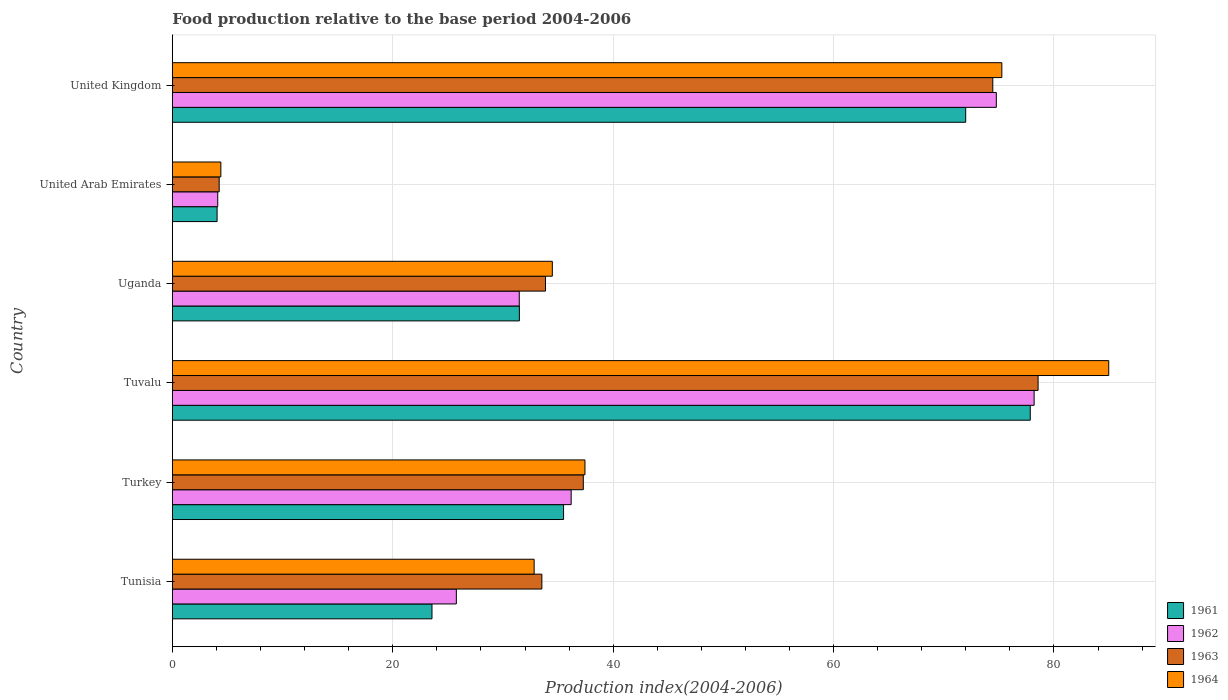Are the number of bars on each tick of the Y-axis equal?
Offer a very short reply. Yes. How many bars are there on the 6th tick from the top?
Provide a succinct answer. 4. What is the food production index in 1964 in Tunisia?
Your answer should be compact. 32.83. Across all countries, what is the maximum food production index in 1963?
Keep it short and to the point. 78.56. Across all countries, what is the minimum food production index in 1964?
Your response must be concise. 4.4. In which country was the food production index in 1963 maximum?
Your response must be concise. Tuvalu. In which country was the food production index in 1961 minimum?
Give a very brief answer. United Arab Emirates. What is the total food production index in 1961 in the graph?
Keep it short and to the point. 244.45. What is the difference between the food production index in 1964 in Uganda and that in United Kingdom?
Keep it short and to the point. -40.79. What is the difference between the food production index in 1961 in Tunisia and the food production index in 1963 in United Kingdom?
Make the answer very short. -50.89. What is the average food production index in 1961 per country?
Keep it short and to the point. 40.74. What is the difference between the food production index in 1961 and food production index in 1964 in United Arab Emirates?
Give a very brief answer. -0.34. What is the ratio of the food production index in 1963 in United Arab Emirates to that in United Kingdom?
Your response must be concise. 0.06. What is the difference between the highest and the second highest food production index in 1962?
Your answer should be compact. 3.43. What is the difference between the highest and the lowest food production index in 1962?
Ensure brevity in your answer.  74.08. What does the 2nd bar from the top in Uganda represents?
Your answer should be very brief. 1963. How many countries are there in the graph?
Your answer should be compact. 6. Are the values on the major ticks of X-axis written in scientific E-notation?
Make the answer very short. No. Does the graph contain grids?
Ensure brevity in your answer.  Yes. Where does the legend appear in the graph?
Your response must be concise. Bottom right. How are the legend labels stacked?
Your answer should be very brief. Vertical. What is the title of the graph?
Provide a succinct answer. Food production relative to the base period 2004-2006. Does "2013" appear as one of the legend labels in the graph?
Your answer should be compact. No. What is the label or title of the X-axis?
Offer a very short reply. Production index(2004-2006). What is the label or title of the Y-axis?
Give a very brief answer. Country. What is the Production index(2004-2006) in 1961 in Tunisia?
Make the answer very short. 23.56. What is the Production index(2004-2006) in 1962 in Tunisia?
Your answer should be very brief. 25.77. What is the Production index(2004-2006) in 1963 in Tunisia?
Ensure brevity in your answer.  33.53. What is the Production index(2004-2006) in 1964 in Tunisia?
Make the answer very short. 32.83. What is the Production index(2004-2006) in 1961 in Turkey?
Offer a terse response. 35.5. What is the Production index(2004-2006) of 1962 in Turkey?
Your answer should be compact. 36.19. What is the Production index(2004-2006) of 1963 in Turkey?
Provide a short and direct response. 37.29. What is the Production index(2004-2006) of 1964 in Turkey?
Offer a very short reply. 37.44. What is the Production index(2004-2006) of 1961 in Tuvalu?
Your response must be concise. 77.85. What is the Production index(2004-2006) of 1962 in Tuvalu?
Make the answer very short. 78.2. What is the Production index(2004-2006) in 1963 in Tuvalu?
Your answer should be compact. 78.56. What is the Production index(2004-2006) in 1964 in Tuvalu?
Provide a succinct answer. 84.97. What is the Production index(2004-2006) of 1961 in Uganda?
Offer a terse response. 31.49. What is the Production index(2004-2006) in 1962 in Uganda?
Offer a terse response. 31.48. What is the Production index(2004-2006) of 1963 in Uganda?
Provide a succinct answer. 33.86. What is the Production index(2004-2006) in 1964 in Uganda?
Your response must be concise. 34.48. What is the Production index(2004-2006) of 1961 in United Arab Emirates?
Offer a terse response. 4.06. What is the Production index(2004-2006) in 1962 in United Arab Emirates?
Provide a succinct answer. 4.12. What is the Production index(2004-2006) of 1963 in United Arab Emirates?
Keep it short and to the point. 4.25. What is the Production index(2004-2006) of 1961 in United Kingdom?
Give a very brief answer. 71.99. What is the Production index(2004-2006) in 1962 in United Kingdom?
Provide a short and direct response. 74.77. What is the Production index(2004-2006) in 1963 in United Kingdom?
Keep it short and to the point. 74.45. What is the Production index(2004-2006) in 1964 in United Kingdom?
Provide a short and direct response. 75.27. Across all countries, what is the maximum Production index(2004-2006) in 1961?
Your response must be concise. 77.85. Across all countries, what is the maximum Production index(2004-2006) of 1962?
Your answer should be very brief. 78.2. Across all countries, what is the maximum Production index(2004-2006) of 1963?
Your answer should be very brief. 78.56. Across all countries, what is the maximum Production index(2004-2006) of 1964?
Ensure brevity in your answer.  84.97. Across all countries, what is the minimum Production index(2004-2006) in 1961?
Give a very brief answer. 4.06. Across all countries, what is the minimum Production index(2004-2006) in 1962?
Your answer should be compact. 4.12. Across all countries, what is the minimum Production index(2004-2006) in 1963?
Your answer should be compact. 4.25. Across all countries, what is the minimum Production index(2004-2006) in 1964?
Your answer should be very brief. 4.4. What is the total Production index(2004-2006) of 1961 in the graph?
Provide a short and direct response. 244.45. What is the total Production index(2004-2006) of 1962 in the graph?
Your answer should be very brief. 250.53. What is the total Production index(2004-2006) of 1963 in the graph?
Offer a terse response. 261.94. What is the total Production index(2004-2006) in 1964 in the graph?
Provide a succinct answer. 269.39. What is the difference between the Production index(2004-2006) of 1961 in Tunisia and that in Turkey?
Offer a terse response. -11.94. What is the difference between the Production index(2004-2006) of 1962 in Tunisia and that in Turkey?
Your answer should be compact. -10.42. What is the difference between the Production index(2004-2006) in 1963 in Tunisia and that in Turkey?
Your answer should be compact. -3.76. What is the difference between the Production index(2004-2006) of 1964 in Tunisia and that in Turkey?
Offer a very short reply. -4.61. What is the difference between the Production index(2004-2006) of 1961 in Tunisia and that in Tuvalu?
Provide a short and direct response. -54.29. What is the difference between the Production index(2004-2006) of 1962 in Tunisia and that in Tuvalu?
Your response must be concise. -52.43. What is the difference between the Production index(2004-2006) in 1963 in Tunisia and that in Tuvalu?
Offer a terse response. -45.03. What is the difference between the Production index(2004-2006) in 1964 in Tunisia and that in Tuvalu?
Your answer should be compact. -52.14. What is the difference between the Production index(2004-2006) in 1961 in Tunisia and that in Uganda?
Provide a short and direct response. -7.93. What is the difference between the Production index(2004-2006) of 1962 in Tunisia and that in Uganda?
Give a very brief answer. -5.71. What is the difference between the Production index(2004-2006) in 1963 in Tunisia and that in Uganda?
Keep it short and to the point. -0.33. What is the difference between the Production index(2004-2006) of 1964 in Tunisia and that in Uganda?
Keep it short and to the point. -1.65. What is the difference between the Production index(2004-2006) in 1961 in Tunisia and that in United Arab Emirates?
Provide a succinct answer. 19.5. What is the difference between the Production index(2004-2006) in 1962 in Tunisia and that in United Arab Emirates?
Give a very brief answer. 21.65. What is the difference between the Production index(2004-2006) in 1963 in Tunisia and that in United Arab Emirates?
Give a very brief answer. 29.28. What is the difference between the Production index(2004-2006) in 1964 in Tunisia and that in United Arab Emirates?
Your answer should be very brief. 28.43. What is the difference between the Production index(2004-2006) in 1961 in Tunisia and that in United Kingdom?
Ensure brevity in your answer.  -48.43. What is the difference between the Production index(2004-2006) of 1962 in Tunisia and that in United Kingdom?
Your response must be concise. -49. What is the difference between the Production index(2004-2006) in 1963 in Tunisia and that in United Kingdom?
Provide a short and direct response. -40.92. What is the difference between the Production index(2004-2006) of 1964 in Tunisia and that in United Kingdom?
Provide a succinct answer. -42.44. What is the difference between the Production index(2004-2006) in 1961 in Turkey and that in Tuvalu?
Make the answer very short. -42.35. What is the difference between the Production index(2004-2006) of 1962 in Turkey and that in Tuvalu?
Keep it short and to the point. -42.01. What is the difference between the Production index(2004-2006) in 1963 in Turkey and that in Tuvalu?
Ensure brevity in your answer.  -41.27. What is the difference between the Production index(2004-2006) in 1964 in Turkey and that in Tuvalu?
Your response must be concise. -47.53. What is the difference between the Production index(2004-2006) in 1961 in Turkey and that in Uganda?
Your answer should be compact. 4.01. What is the difference between the Production index(2004-2006) in 1962 in Turkey and that in Uganda?
Provide a succinct answer. 4.71. What is the difference between the Production index(2004-2006) in 1963 in Turkey and that in Uganda?
Ensure brevity in your answer.  3.43. What is the difference between the Production index(2004-2006) in 1964 in Turkey and that in Uganda?
Make the answer very short. 2.96. What is the difference between the Production index(2004-2006) of 1961 in Turkey and that in United Arab Emirates?
Offer a terse response. 31.44. What is the difference between the Production index(2004-2006) in 1962 in Turkey and that in United Arab Emirates?
Ensure brevity in your answer.  32.07. What is the difference between the Production index(2004-2006) of 1963 in Turkey and that in United Arab Emirates?
Give a very brief answer. 33.04. What is the difference between the Production index(2004-2006) of 1964 in Turkey and that in United Arab Emirates?
Provide a short and direct response. 33.04. What is the difference between the Production index(2004-2006) of 1961 in Turkey and that in United Kingdom?
Offer a terse response. -36.49. What is the difference between the Production index(2004-2006) in 1962 in Turkey and that in United Kingdom?
Offer a very short reply. -38.58. What is the difference between the Production index(2004-2006) of 1963 in Turkey and that in United Kingdom?
Ensure brevity in your answer.  -37.16. What is the difference between the Production index(2004-2006) of 1964 in Turkey and that in United Kingdom?
Provide a succinct answer. -37.83. What is the difference between the Production index(2004-2006) in 1961 in Tuvalu and that in Uganda?
Your answer should be compact. 46.36. What is the difference between the Production index(2004-2006) of 1962 in Tuvalu and that in Uganda?
Your answer should be compact. 46.72. What is the difference between the Production index(2004-2006) in 1963 in Tuvalu and that in Uganda?
Provide a succinct answer. 44.7. What is the difference between the Production index(2004-2006) in 1964 in Tuvalu and that in Uganda?
Offer a very short reply. 50.49. What is the difference between the Production index(2004-2006) in 1961 in Tuvalu and that in United Arab Emirates?
Your answer should be compact. 73.79. What is the difference between the Production index(2004-2006) of 1962 in Tuvalu and that in United Arab Emirates?
Your answer should be very brief. 74.08. What is the difference between the Production index(2004-2006) of 1963 in Tuvalu and that in United Arab Emirates?
Your answer should be very brief. 74.31. What is the difference between the Production index(2004-2006) in 1964 in Tuvalu and that in United Arab Emirates?
Keep it short and to the point. 80.57. What is the difference between the Production index(2004-2006) in 1961 in Tuvalu and that in United Kingdom?
Your answer should be compact. 5.86. What is the difference between the Production index(2004-2006) in 1962 in Tuvalu and that in United Kingdom?
Offer a terse response. 3.43. What is the difference between the Production index(2004-2006) of 1963 in Tuvalu and that in United Kingdom?
Give a very brief answer. 4.11. What is the difference between the Production index(2004-2006) in 1961 in Uganda and that in United Arab Emirates?
Make the answer very short. 27.43. What is the difference between the Production index(2004-2006) of 1962 in Uganda and that in United Arab Emirates?
Keep it short and to the point. 27.36. What is the difference between the Production index(2004-2006) of 1963 in Uganda and that in United Arab Emirates?
Ensure brevity in your answer.  29.61. What is the difference between the Production index(2004-2006) in 1964 in Uganda and that in United Arab Emirates?
Make the answer very short. 30.08. What is the difference between the Production index(2004-2006) of 1961 in Uganda and that in United Kingdom?
Your response must be concise. -40.5. What is the difference between the Production index(2004-2006) of 1962 in Uganda and that in United Kingdom?
Make the answer very short. -43.29. What is the difference between the Production index(2004-2006) in 1963 in Uganda and that in United Kingdom?
Ensure brevity in your answer.  -40.59. What is the difference between the Production index(2004-2006) in 1964 in Uganda and that in United Kingdom?
Provide a short and direct response. -40.79. What is the difference between the Production index(2004-2006) of 1961 in United Arab Emirates and that in United Kingdom?
Offer a terse response. -67.93. What is the difference between the Production index(2004-2006) of 1962 in United Arab Emirates and that in United Kingdom?
Give a very brief answer. -70.65. What is the difference between the Production index(2004-2006) in 1963 in United Arab Emirates and that in United Kingdom?
Your answer should be compact. -70.2. What is the difference between the Production index(2004-2006) of 1964 in United Arab Emirates and that in United Kingdom?
Your response must be concise. -70.87. What is the difference between the Production index(2004-2006) in 1961 in Tunisia and the Production index(2004-2006) in 1962 in Turkey?
Offer a very short reply. -12.63. What is the difference between the Production index(2004-2006) of 1961 in Tunisia and the Production index(2004-2006) of 1963 in Turkey?
Offer a very short reply. -13.73. What is the difference between the Production index(2004-2006) in 1961 in Tunisia and the Production index(2004-2006) in 1964 in Turkey?
Keep it short and to the point. -13.88. What is the difference between the Production index(2004-2006) of 1962 in Tunisia and the Production index(2004-2006) of 1963 in Turkey?
Offer a terse response. -11.52. What is the difference between the Production index(2004-2006) of 1962 in Tunisia and the Production index(2004-2006) of 1964 in Turkey?
Offer a terse response. -11.67. What is the difference between the Production index(2004-2006) of 1963 in Tunisia and the Production index(2004-2006) of 1964 in Turkey?
Ensure brevity in your answer.  -3.91. What is the difference between the Production index(2004-2006) in 1961 in Tunisia and the Production index(2004-2006) in 1962 in Tuvalu?
Give a very brief answer. -54.64. What is the difference between the Production index(2004-2006) of 1961 in Tunisia and the Production index(2004-2006) of 1963 in Tuvalu?
Provide a short and direct response. -55. What is the difference between the Production index(2004-2006) of 1961 in Tunisia and the Production index(2004-2006) of 1964 in Tuvalu?
Provide a succinct answer. -61.41. What is the difference between the Production index(2004-2006) of 1962 in Tunisia and the Production index(2004-2006) of 1963 in Tuvalu?
Provide a succinct answer. -52.79. What is the difference between the Production index(2004-2006) in 1962 in Tunisia and the Production index(2004-2006) in 1964 in Tuvalu?
Provide a short and direct response. -59.2. What is the difference between the Production index(2004-2006) in 1963 in Tunisia and the Production index(2004-2006) in 1964 in Tuvalu?
Your response must be concise. -51.44. What is the difference between the Production index(2004-2006) in 1961 in Tunisia and the Production index(2004-2006) in 1962 in Uganda?
Provide a short and direct response. -7.92. What is the difference between the Production index(2004-2006) of 1961 in Tunisia and the Production index(2004-2006) of 1964 in Uganda?
Ensure brevity in your answer.  -10.92. What is the difference between the Production index(2004-2006) of 1962 in Tunisia and the Production index(2004-2006) of 1963 in Uganda?
Your answer should be compact. -8.09. What is the difference between the Production index(2004-2006) of 1962 in Tunisia and the Production index(2004-2006) of 1964 in Uganda?
Offer a very short reply. -8.71. What is the difference between the Production index(2004-2006) of 1963 in Tunisia and the Production index(2004-2006) of 1964 in Uganda?
Keep it short and to the point. -0.95. What is the difference between the Production index(2004-2006) in 1961 in Tunisia and the Production index(2004-2006) in 1962 in United Arab Emirates?
Keep it short and to the point. 19.44. What is the difference between the Production index(2004-2006) in 1961 in Tunisia and the Production index(2004-2006) in 1963 in United Arab Emirates?
Ensure brevity in your answer.  19.31. What is the difference between the Production index(2004-2006) of 1961 in Tunisia and the Production index(2004-2006) of 1964 in United Arab Emirates?
Give a very brief answer. 19.16. What is the difference between the Production index(2004-2006) in 1962 in Tunisia and the Production index(2004-2006) in 1963 in United Arab Emirates?
Your response must be concise. 21.52. What is the difference between the Production index(2004-2006) of 1962 in Tunisia and the Production index(2004-2006) of 1964 in United Arab Emirates?
Keep it short and to the point. 21.37. What is the difference between the Production index(2004-2006) of 1963 in Tunisia and the Production index(2004-2006) of 1964 in United Arab Emirates?
Your answer should be compact. 29.13. What is the difference between the Production index(2004-2006) of 1961 in Tunisia and the Production index(2004-2006) of 1962 in United Kingdom?
Your response must be concise. -51.21. What is the difference between the Production index(2004-2006) of 1961 in Tunisia and the Production index(2004-2006) of 1963 in United Kingdom?
Ensure brevity in your answer.  -50.89. What is the difference between the Production index(2004-2006) of 1961 in Tunisia and the Production index(2004-2006) of 1964 in United Kingdom?
Your response must be concise. -51.71. What is the difference between the Production index(2004-2006) in 1962 in Tunisia and the Production index(2004-2006) in 1963 in United Kingdom?
Keep it short and to the point. -48.68. What is the difference between the Production index(2004-2006) of 1962 in Tunisia and the Production index(2004-2006) of 1964 in United Kingdom?
Your answer should be compact. -49.5. What is the difference between the Production index(2004-2006) in 1963 in Tunisia and the Production index(2004-2006) in 1964 in United Kingdom?
Offer a terse response. -41.74. What is the difference between the Production index(2004-2006) of 1961 in Turkey and the Production index(2004-2006) of 1962 in Tuvalu?
Your response must be concise. -42.7. What is the difference between the Production index(2004-2006) in 1961 in Turkey and the Production index(2004-2006) in 1963 in Tuvalu?
Offer a terse response. -43.06. What is the difference between the Production index(2004-2006) in 1961 in Turkey and the Production index(2004-2006) in 1964 in Tuvalu?
Ensure brevity in your answer.  -49.47. What is the difference between the Production index(2004-2006) of 1962 in Turkey and the Production index(2004-2006) of 1963 in Tuvalu?
Your answer should be very brief. -42.37. What is the difference between the Production index(2004-2006) in 1962 in Turkey and the Production index(2004-2006) in 1964 in Tuvalu?
Ensure brevity in your answer.  -48.78. What is the difference between the Production index(2004-2006) in 1963 in Turkey and the Production index(2004-2006) in 1964 in Tuvalu?
Offer a very short reply. -47.68. What is the difference between the Production index(2004-2006) in 1961 in Turkey and the Production index(2004-2006) in 1962 in Uganda?
Provide a short and direct response. 4.02. What is the difference between the Production index(2004-2006) of 1961 in Turkey and the Production index(2004-2006) of 1963 in Uganda?
Give a very brief answer. 1.64. What is the difference between the Production index(2004-2006) of 1962 in Turkey and the Production index(2004-2006) of 1963 in Uganda?
Ensure brevity in your answer.  2.33. What is the difference between the Production index(2004-2006) of 1962 in Turkey and the Production index(2004-2006) of 1964 in Uganda?
Offer a very short reply. 1.71. What is the difference between the Production index(2004-2006) of 1963 in Turkey and the Production index(2004-2006) of 1964 in Uganda?
Give a very brief answer. 2.81. What is the difference between the Production index(2004-2006) in 1961 in Turkey and the Production index(2004-2006) in 1962 in United Arab Emirates?
Keep it short and to the point. 31.38. What is the difference between the Production index(2004-2006) in 1961 in Turkey and the Production index(2004-2006) in 1963 in United Arab Emirates?
Make the answer very short. 31.25. What is the difference between the Production index(2004-2006) in 1961 in Turkey and the Production index(2004-2006) in 1964 in United Arab Emirates?
Provide a short and direct response. 31.1. What is the difference between the Production index(2004-2006) of 1962 in Turkey and the Production index(2004-2006) of 1963 in United Arab Emirates?
Offer a terse response. 31.94. What is the difference between the Production index(2004-2006) of 1962 in Turkey and the Production index(2004-2006) of 1964 in United Arab Emirates?
Your answer should be compact. 31.79. What is the difference between the Production index(2004-2006) in 1963 in Turkey and the Production index(2004-2006) in 1964 in United Arab Emirates?
Keep it short and to the point. 32.89. What is the difference between the Production index(2004-2006) in 1961 in Turkey and the Production index(2004-2006) in 1962 in United Kingdom?
Your answer should be very brief. -39.27. What is the difference between the Production index(2004-2006) in 1961 in Turkey and the Production index(2004-2006) in 1963 in United Kingdom?
Your answer should be very brief. -38.95. What is the difference between the Production index(2004-2006) of 1961 in Turkey and the Production index(2004-2006) of 1964 in United Kingdom?
Offer a very short reply. -39.77. What is the difference between the Production index(2004-2006) in 1962 in Turkey and the Production index(2004-2006) in 1963 in United Kingdom?
Provide a succinct answer. -38.26. What is the difference between the Production index(2004-2006) in 1962 in Turkey and the Production index(2004-2006) in 1964 in United Kingdom?
Offer a terse response. -39.08. What is the difference between the Production index(2004-2006) in 1963 in Turkey and the Production index(2004-2006) in 1964 in United Kingdom?
Provide a succinct answer. -37.98. What is the difference between the Production index(2004-2006) of 1961 in Tuvalu and the Production index(2004-2006) of 1962 in Uganda?
Offer a terse response. 46.37. What is the difference between the Production index(2004-2006) in 1961 in Tuvalu and the Production index(2004-2006) in 1963 in Uganda?
Provide a short and direct response. 43.99. What is the difference between the Production index(2004-2006) of 1961 in Tuvalu and the Production index(2004-2006) of 1964 in Uganda?
Ensure brevity in your answer.  43.37. What is the difference between the Production index(2004-2006) in 1962 in Tuvalu and the Production index(2004-2006) in 1963 in Uganda?
Give a very brief answer. 44.34. What is the difference between the Production index(2004-2006) in 1962 in Tuvalu and the Production index(2004-2006) in 1964 in Uganda?
Make the answer very short. 43.72. What is the difference between the Production index(2004-2006) in 1963 in Tuvalu and the Production index(2004-2006) in 1964 in Uganda?
Your response must be concise. 44.08. What is the difference between the Production index(2004-2006) of 1961 in Tuvalu and the Production index(2004-2006) of 1962 in United Arab Emirates?
Give a very brief answer. 73.73. What is the difference between the Production index(2004-2006) of 1961 in Tuvalu and the Production index(2004-2006) of 1963 in United Arab Emirates?
Your answer should be compact. 73.6. What is the difference between the Production index(2004-2006) in 1961 in Tuvalu and the Production index(2004-2006) in 1964 in United Arab Emirates?
Offer a very short reply. 73.45. What is the difference between the Production index(2004-2006) of 1962 in Tuvalu and the Production index(2004-2006) of 1963 in United Arab Emirates?
Make the answer very short. 73.95. What is the difference between the Production index(2004-2006) in 1962 in Tuvalu and the Production index(2004-2006) in 1964 in United Arab Emirates?
Your answer should be compact. 73.8. What is the difference between the Production index(2004-2006) of 1963 in Tuvalu and the Production index(2004-2006) of 1964 in United Arab Emirates?
Your answer should be compact. 74.16. What is the difference between the Production index(2004-2006) in 1961 in Tuvalu and the Production index(2004-2006) in 1962 in United Kingdom?
Ensure brevity in your answer.  3.08. What is the difference between the Production index(2004-2006) of 1961 in Tuvalu and the Production index(2004-2006) of 1964 in United Kingdom?
Your response must be concise. 2.58. What is the difference between the Production index(2004-2006) of 1962 in Tuvalu and the Production index(2004-2006) of 1963 in United Kingdom?
Keep it short and to the point. 3.75. What is the difference between the Production index(2004-2006) of 1962 in Tuvalu and the Production index(2004-2006) of 1964 in United Kingdom?
Ensure brevity in your answer.  2.93. What is the difference between the Production index(2004-2006) of 1963 in Tuvalu and the Production index(2004-2006) of 1964 in United Kingdom?
Provide a succinct answer. 3.29. What is the difference between the Production index(2004-2006) in 1961 in Uganda and the Production index(2004-2006) in 1962 in United Arab Emirates?
Ensure brevity in your answer.  27.37. What is the difference between the Production index(2004-2006) of 1961 in Uganda and the Production index(2004-2006) of 1963 in United Arab Emirates?
Your response must be concise. 27.24. What is the difference between the Production index(2004-2006) in 1961 in Uganda and the Production index(2004-2006) in 1964 in United Arab Emirates?
Keep it short and to the point. 27.09. What is the difference between the Production index(2004-2006) of 1962 in Uganda and the Production index(2004-2006) of 1963 in United Arab Emirates?
Offer a very short reply. 27.23. What is the difference between the Production index(2004-2006) of 1962 in Uganda and the Production index(2004-2006) of 1964 in United Arab Emirates?
Your answer should be very brief. 27.08. What is the difference between the Production index(2004-2006) in 1963 in Uganda and the Production index(2004-2006) in 1964 in United Arab Emirates?
Your answer should be compact. 29.46. What is the difference between the Production index(2004-2006) in 1961 in Uganda and the Production index(2004-2006) in 1962 in United Kingdom?
Make the answer very short. -43.28. What is the difference between the Production index(2004-2006) in 1961 in Uganda and the Production index(2004-2006) in 1963 in United Kingdom?
Your response must be concise. -42.96. What is the difference between the Production index(2004-2006) of 1961 in Uganda and the Production index(2004-2006) of 1964 in United Kingdom?
Your answer should be compact. -43.78. What is the difference between the Production index(2004-2006) in 1962 in Uganda and the Production index(2004-2006) in 1963 in United Kingdom?
Your answer should be very brief. -42.97. What is the difference between the Production index(2004-2006) of 1962 in Uganda and the Production index(2004-2006) of 1964 in United Kingdom?
Give a very brief answer. -43.79. What is the difference between the Production index(2004-2006) in 1963 in Uganda and the Production index(2004-2006) in 1964 in United Kingdom?
Your answer should be very brief. -41.41. What is the difference between the Production index(2004-2006) in 1961 in United Arab Emirates and the Production index(2004-2006) in 1962 in United Kingdom?
Offer a terse response. -70.71. What is the difference between the Production index(2004-2006) in 1961 in United Arab Emirates and the Production index(2004-2006) in 1963 in United Kingdom?
Provide a succinct answer. -70.39. What is the difference between the Production index(2004-2006) of 1961 in United Arab Emirates and the Production index(2004-2006) of 1964 in United Kingdom?
Offer a terse response. -71.21. What is the difference between the Production index(2004-2006) of 1962 in United Arab Emirates and the Production index(2004-2006) of 1963 in United Kingdom?
Provide a succinct answer. -70.33. What is the difference between the Production index(2004-2006) in 1962 in United Arab Emirates and the Production index(2004-2006) in 1964 in United Kingdom?
Ensure brevity in your answer.  -71.15. What is the difference between the Production index(2004-2006) of 1963 in United Arab Emirates and the Production index(2004-2006) of 1964 in United Kingdom?
Provide a succinct answer. -71.02. What is the average Production index(2004-2006) of 1961 per country?
Your answer should be very brief. 40.74. What is the average Production index(2004-2006) of 1962 per country?
Offer a terse response. 41.76. What is the average Production index(2004-2006) in 1963 per country?
Make the answer very short. 43.66. What is the average Production index(2004-2006) in 1964 per country?
Make the answer very short. 44.9. What is the difference between the Production index(2004-2006) of 1961 and Production index(2004-2006) of 1962 in Tunisia?
Your response must be concise. -2.21. What is the difference between the Production index(2004-2006) in 1961 and Production index(2004-2006) in 1963 in Tunisia?
Offer a very short reply. -9.97. What is the difference between the Production index(2004-2006) in 1961 and Production index(2004-2006) in 1964 in Tunisia?
Provide a succinct answer. -9.27. What is the difference between the Production index(2004-2006) of 1962 and Production index(2004-2006) of 1963 in Tunisia?
Offer a terse response. -7.76. What is the difference between the Production index(2004-2006) of 1962 and Production index(2004-2006) of 1964 in Tunisia?
Give a very brief answer. -7.06. What is the difference between the Production index(2004-2006) of 1961 and Production index(2004-2006) of 1962 in Turkey?
Give a very brief answer. -0.69. What is the difference between the Production index(2004-2006) in 1961 and Production index(2004-2006) in 1963 in Turkey?
Make the answer very short. -1.79. What is the difference between the Production index(2004-2006) in 1961 and Production index(2004-2006) in 1964 in Turkey?
Ensure brevity in your answer.  -1.94. What is the difference between the Production index(2004-2006) of 1962 and Production index(2004-2006) of 1963 in Turkey?
Keep it short and to the point. -1.1. What is the difference between the Production index(2004-2006) in 1962 and Production index(2004-2006) in 1964 in Turkey?
Your answer should be compact. -1.25. What is the difference between the Production index(2004-2006) in 1961 and Production index(2004-2006) in 1962 in Tuvalu?
Make the answer very short. -0.35. What is the difference between the Production index(2004-2006) of 1961 and Production index(2004-2006) of 1963 in Tuvalu?
Offer a very short reply. -0.71. What is the difference between the Production index(2004-2006) of 1961 and Production index(2004-2006) of 1964 in Tuvalu?
Provide a short and direct response. -7.12. What is the difference between the Production index(2004-2006) of 1962 and Production index(2004-2006) of 1963 in Tuvalu?
Give a very brief answer. -0.36. What is the difference between the Production index(2004-2006) in 1962 and Production index(2004-2006) in 1964 in Tuvalu?
Make the answer very short. -6.77. What is the difference between the Production index(2004-2006) of 1963 and Production index(2004-2006) of 1964 in Tuvalu?
Offer a very short reply. -6.41. What is the difference between the Production index(2004-2006) in 1961 and Production index(2004-2006) in 1962 in Uganda?
Your answer should be compact. 0.01. What is the difference between the Production index(2004-2006) of 1961 and Production index(2004-2006) of 1963 in Uganda?
Offer a very short reply. -2.37. What is the difference between the Production index(2004-2006) in 1961 and Production index(2004-2006) in 1964 in Uganda?
Your answer should be compact. -2.99. What is the difference between the Production index(2004-2006) in 1962 and Production index(2004-2006) in 1963 in Uganda?
Your answer should be very brief. -2.38. What is the difference between the Production index(2004-2006) of 1962 and Production index(2004-2006) of 1964 in Uganda?
Your response must be concise. -3. What is the difference between the Production index(2004-2006) in 1963 and Production index(2004-2006) in 1964 in Uganda?
Make the answer very short. -0.62. What is the difference between the Production index(2004-2006) in 1961 and Production index(2004-2006) in 1962 in United Arab Emirates?
Provide a succinct answer. -0.06. What is the difference between the Production index(2004-2006) of 1961 and Production index(2004-2006) of 1963 in United Arab Emirates?
Provide a short and direct response. -0.19. What is the difference between the Production index(2004-2006) of 1961 and Production index(2004-2006) of 1964 in United Arab Emirates?
Offer a terse response. -0.34. What is the difference between the Production index(2004-2006) in 1962 and Production index(2004-2006) in 1963 in United Arab Emirates?
Your answer should be very brief. -0.13. What is the difference between the Production index(2004-2006) in 1962 and Production index(2004-2006) in 1964 in United Arab Emirates?
Offer a very short reply. -0.28. What is the difference between the Production index(2004-2006) of 1961 and Production index(2004-2006) of 1962 in United Kingdom?
Offer a terse response. -2.78. What is the difference between the Production index(2004-2006) in 1961 and Production index(2004-2006) in 1963 in United Kingdom?
Provide a short and direct response. -2.46. What is the difference between the Production index(2004-2006) of 1961 and Production index(2004-2006) of 1964 in United Kingdom?
Your answer should be very brief. -3.28. What is the difference between the Production index(2004-2006) of 1962 and Production index(2004-2006) of 1963 in United Kingdom?
Offer a terse response. 0.32. What is the difference between the Production index(2004-2006) of 1962 and Production index(2004-2006) of 1964 in United Kingdom?
Keep it short and to the point. -0.5. What is the difference between the Production index(2004-2006) in 1963 and Production index(2004-2006) in 1964 in United Kingdom?
Offer a very short reply. -0.82. What is the ratio of the Production index(2004-2006) of 1961 in Tunisia to that in Turkey?
Make the answer very short. 0.66. What is the ratio of the Production index(2004-2006) of 1962 in Tunisia to that in Turkey?
Ensure brevity in your answer.  0.71. What is the ratio of the Production index(2004-2006) in 1963 in Tunisia to that in Turkey?
Your answer should be very brief. 0.9. What is the ratio of the Production index(2004-2006) in 1964 in Tunisia to that in Turkey?
Keep it short and to the point. 0.88. What is the ratio of the Production index(2004-2006) of 1961 in Tunisia to that in Tuvalu?
Make the answer very short. 0.3. What is the ratio of the Production index(2004-2006) in 1962 in Tunisia to that in Tuvalu?
Your response must be concise. 0.33. What is the ratio of the Production index(2004-2006) of 1963 in Tunisia to that in Tuvalu?
Keep it short and to the point. 0.43. What is the ratio of the Production index(2004-2006) of 1964 in Tunisia to that in Tuvalu?
Your answer should be compact. 0.39. What is the ratio of the Production index(2004-2006) in 1961 in Tunisia to that in Uganda?
Offer a very short reply. 0.75. What is the ratio of the Production index(2004-2006) in 1962 in Tunisia to that in Uganda?
Keep it short and to the point. 0.82. What is the ratio of the Production index(2004-2006) in 1963 in Tunisia to that in Uganda?
Your response must be concise. 0.99. What is the ratio of the Production index(2004-2006) in 1964 in Tunisia to that in Uganda?
Keep it short and to the point. 0.95. What is the ratio of the Production index(2004-2006) in 1961 in Tunisia to that in United Arab Emirates?
Offer a very short reply. 5.8. What is the ratio of the Production index(2004-2006) of 1962 in Tunisia to that in United Arab Emirates?
Offer a terse response. 6.25. What is the ratio of the Production index(2004-2006) of 1963 in Tunisia to that in United Arab Emirates?
Keep it short and to the point. 7.89. What is the ratio of the Production index(2004-2006) of 1964 in Tunisia to that in United Arab Emirates?
Ensure brevity in your answer.  7.46. What is the ratio of the Production index(2004-2006) in 1961 in Tunisia to that in United Kingdom?
Make the answer very short. 0.33. What is the ratio of the Production index(2004-2006) of 1962 in Tunisia to that in United Kingdom?
Your answer should be compact. 0.34. What is the ratio of the Production index(2004-2006) in 1963 in Tunisia to that in United Kingdom?
Give a very brief answer. 0.45. What is the ratio of the Production index(2004-2006) of 1964 in Tunisia to that in United Kingdom?
Your answer should be compact. 0.44. What is the ratio of the Production index(2004-2006) in 1961 in Turkey to that in Tuvalu?
Offer a very short reply. 0.46. What is the ratio of the Production index(2004-2006) of 1962 in Turkey to that in Tuvalu?
Your answer should be very brief. 0.46. What is the ratio of the Production index(2004-2006) in 1963 in Turkey to that in Tuvalu?
Your answer should be compact. 0.47. What is the ratio of the Production index(2004-2006) in 1964 in Turkey to that in Tuvalu?
Provide a succinct answer. 0.44. What is the ratio of the Production index(2004-2006) in 1961 in Turkey to that in Uganda?
Your response must be concise. 1.13. What is the ratio of the Production index(2004-2006) of 1962 in Turkey to that in Uganda?
Provide a succinct answer. 1.15. What is the ratio of the Production index(2004-2006) of 1963 in Turkey to that in Uganda?
Provide a short and direct response. 1.1. What is the ratio of the Production index(2004-2006) of 1964 in Turkey to that in Uganda?
Keep it short and to the point. 1.09. What is the ratio of the Production index(2004-2006) of 1961 in Turkey to that in United Arab Emirates?
Ensure brevity in your answer.  8.74. What is the ratio of the Production index(2004-2006) in 1962 in Turkey to that in United Arab Emirates?
Ensure brevity in your answer.  8.78. What is the ratio of the Production index(2004-2006) of 1963 in Turkey to that in United Arab Emirates?
Ensure brevity in your answer.  8.77. What is the ratio of the Production index(2004-2006) of 1964 in Turkey to that in United Arab Emirates?
Ensure brevity in your answer.  8.51. What is the ratio of the Production index(2004-2006) in 1961 in Turkey to that in United Kingdom?
Keep it short and to the point. 0.49. What is the ratio of the Production index(2004-2006) of 1962 in Turkey to that in United Kingdom?
Keep it short and to the point. 0.48. What is the ratio of the Production index(2004-2006) in 1963 in Turkey to that in United Kingdom?
Offer a very short reply. 0.5. What is the ratio of the Production index(2004-2006) of 1964 in Turkey to that in United Kingdom?
Provide a succinct answer. 0.5. What is the ratio of the Production index(2004-2006) of 1961 in Tuvalu to that in Uganda?
Make the answer very short. 2.47. What is the ratio of the Production index(2004-2006) in 1962 in Tuvalu to that in Uganda?
Your answer should be very brief. 2.48. What is the ratio of the Production index(2004-2006) of 1963 in Tuvalu to that in Uganda?
Your answer should be compact. 2.32. What is the ratio of the Production index(2004-2006) of 1964 in Tuvalu to that in Uganda?
Provide a succinct answer. 2.46. What is the ratio of the Production index(2004-2006) of 1961 in Tuvalu to that in United Arab Emirates?
Your answer should be very brief. 19.17. What is the ratio of the Production index(2004-2006) in 1962 in Tuvalu to that in United Arab Emirates?
Offer a terse response. 18.98. What is the ratio of the Production index(2004-2006) in 1963 in Tuvalu to that in United Arab Emirates?
Ensure brevity in your answer.  18.48. What is the ratio of the Production index(2004-2006) in 1964 in Tuvalu to that in United Arab Emirates?
Your response must be concise. 19.31. What is the ratio of the Production index(2004-2006) of 1961 in Tuvalu to that in United Kingdom?
Your answer should be compact. 1.08. What is the ratio of the Production index(2004-2006) of 1962 in Tuvalu to that in United Kingdom?
Provide a succinct answer. 1.05. What is the ratio of the Production index(2004-2006) in 1963 in Tuvalu to that in United Kingdom?
Offer a terse response. 1.06. What is the ratio of the Production index(2004-2006) in 1964 in Tuvalu to that in United Kingdom?
Your answer should be very brief. 1.13. What is the ratio of the Production index(2004-2006) in 1961 in Uganda to that in United Arab Emirates?
Give a very brief answer. 7.76. What is the ratio of the Production index(2004-2006) of 1962 in Uganda to that in United Arab Emirates?
Give a very brief answer. 7.64. What is the ratio of the Production index(2004-2006) in 1963 in Uganda to that in United Arab Emirates?
Make the answer very short. 7.97. What is the ratio of the Production index(2004-2006) of 1964 in Uganda to that in United Arab Emirates?
Your response must be concise. 7.84. What is the ratio of the Production index(2004-2006) in 1961 in Uganda to that in United Kingdom?
Keep it short and to the point. 0.44. What is the ratio of the Production index(2004-2006) in 1962 in Uganda to that in United Kingdom?
Your answer should be very brief. 0.42. What is the ratio of the Production index(2004-2006) of 1963 in Uganda to that in United Kingdom?
Your answer should be very brief. 0.45. What is the ratio of the Production index(2004-2006) in 1964 in Uganda to that in United Kingdom?
Make the answer very short. 0.46. What is the ratio of the Production index(2004-2006) of 1961 in United Arab Emirates to that in United Kingdom?
Your response must be concise. 0.06. What is the ratio of the Production index(2004-2006) in 1962 in United Arab Emirates to that in United Kingdom?
Ensure brevity in your answer.  0.06. What is the ratio of the Production index(2004-2006) in 1963 in United Arab Emirates to that in United Kingdom?
Ensure brevity in your answer.  0.06. What is the ratio of the Production index(2004-2006) in 1964 in United Arab Emirates to that in United Kingdom?
Your answer should be compact. 0.06. What is the difference between the highest and the second highest Production index(2004-2006) of 1961?
Give a very brief answer. 5.86. What is the difference between the highest and the second highest Production index(2004-2006) of 1962?
Provide a succinct answer. 3.43. What is the difference between the highest and the second highest Production index(2004-2006) of 1963?
Provide a short and direct response. 4.11. What is the difference between the highest and the lowest Production index(2004-2006) of 1961?
Ensure brevity in your answer.  73.79. What is the difference between the highest and the lowest Production index(2004-2006) of 1962?
Provide a short and direct response. 74.08. What is the difference between the highest and the lowest Production index(2004-2006) of 1963?
Provide a succinct answer. 74.31. What is the difference between the highest and the lowest Production index(2004-2006) of 1964?
Provide a succinct answer. 80.57. 